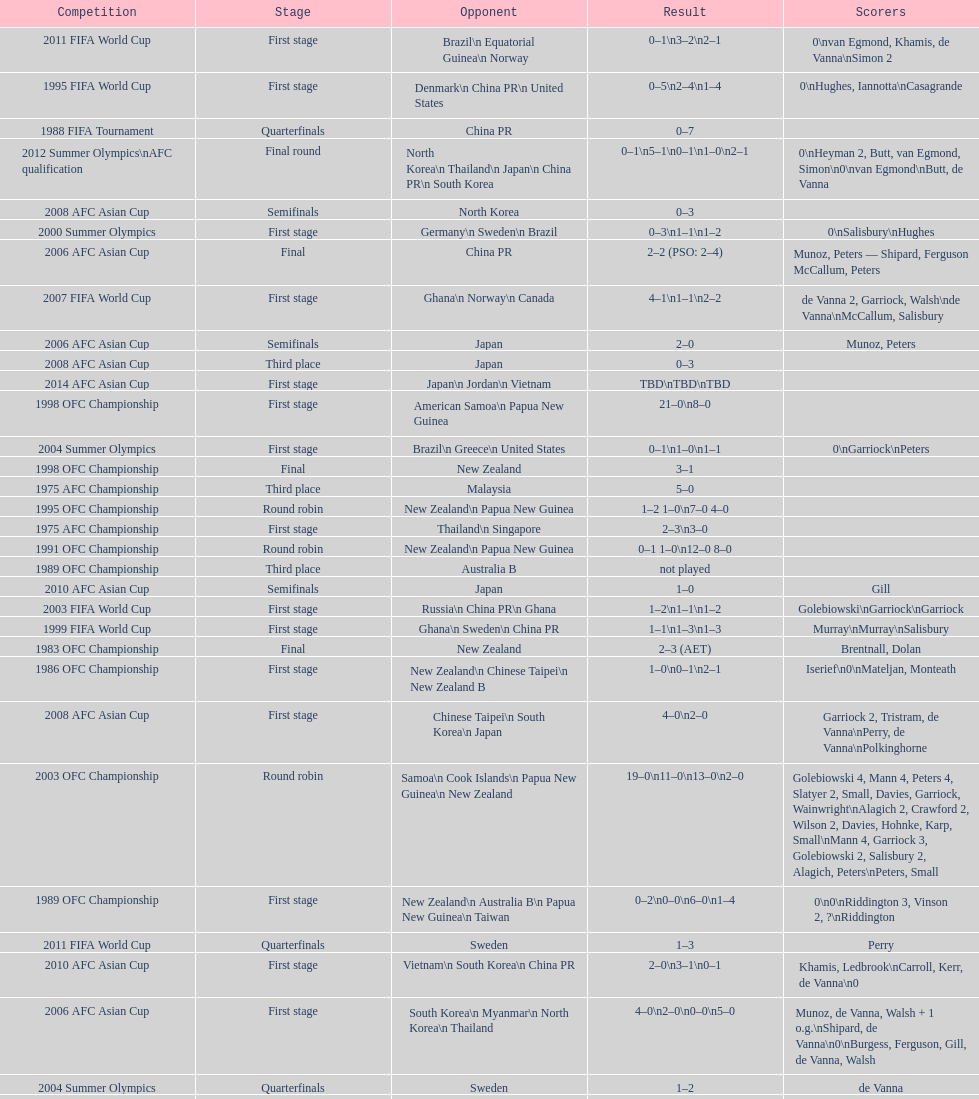How many stages were round robins? 3. 